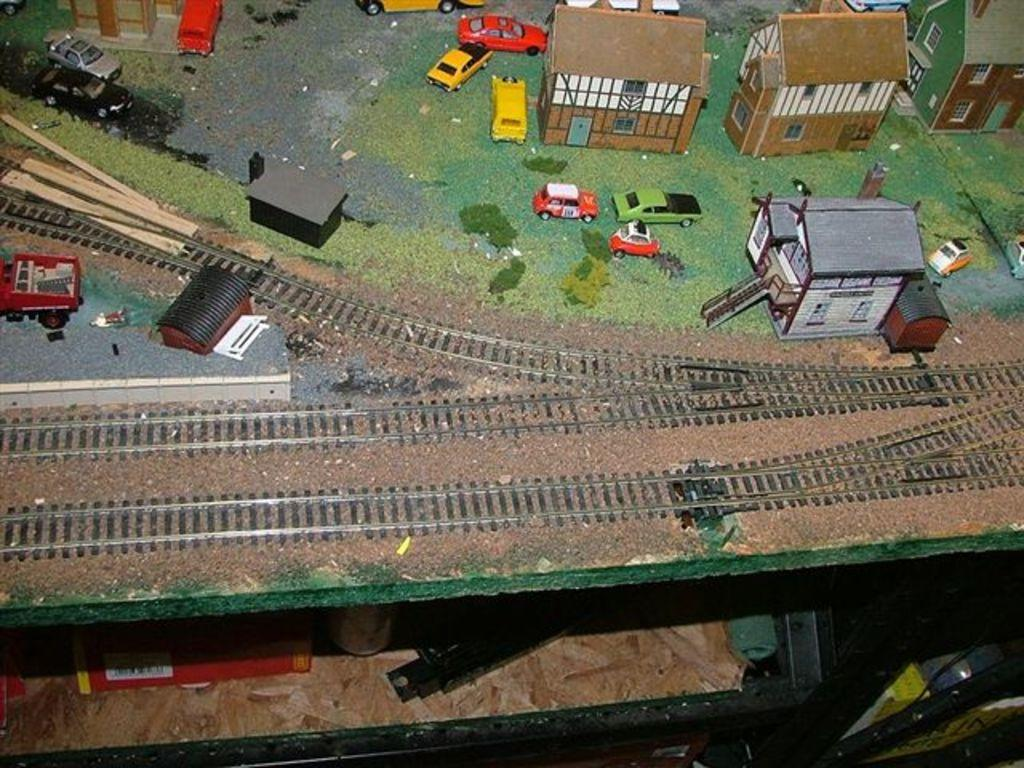What type of toys can be seen in the image? There are miniature toys in the image. What is the setting for the toys in the image? The toys are on a railway track in the image. What structures are present in the image? There is a shed, a building, and a house in the image. What vehicles are visible in the image? There are cars in the image. What type of terrain is present in the image? There is grass in the image. What other objects can be seen in the image? There are other objects in the image, including a drawer and a book on the table. What is the reason for the protest happening in the image? There is no protest present in the image; it features miniature toys, a railway track, and other objects. 